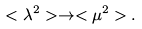<formula> <loc_0><loc_0><loc_500><loc_500>< \lambda ^ { 2 } > \rightarrow < \mu ^ { 2 } > .</formula> 